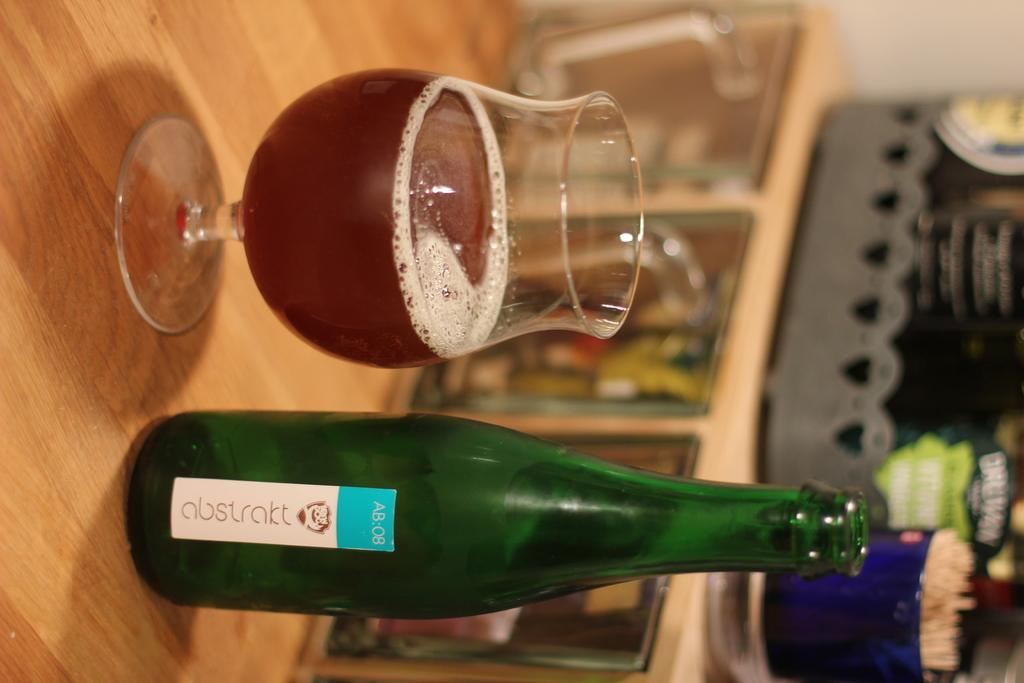What color is the bottle in the image? The bottle in the image is green-colored. What is the glass in the image used for? The glass in the image contains liquid. Where are the bottle and the glass located in the image? Both the bottle and the glass are on a table. What is the distance between the bottle and the mom in the image? There is no mention of a mom in the image, so it is not possible to determine the distance between the bottle and a mom. 